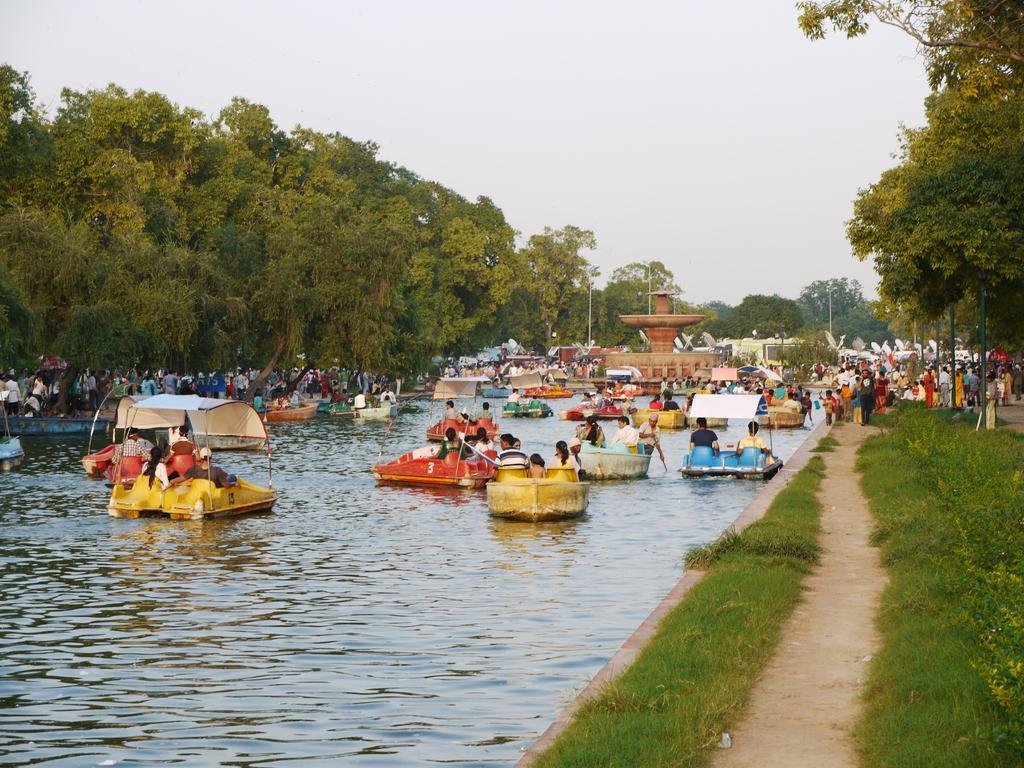What is the main subject of the image? The main subject of the image is water. What is on the water in the image? There are boats on the water. Who is in the boats? There are people sitting in the boats. What type of vegetation can be seen in the image? There are green trees visible in the image. What is visible at the top of the image? The sky is visible at the top of the image. How much salt is in the water in the image? The provided facts do not mention anything about salt in the water, so we cannot determine the salt content from the image. 